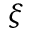<formula> <loc_0><loc_0><loc_500><loc_500>\xi</formula> 